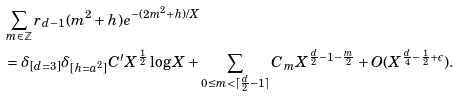Convert formula to latex. <formula><loc_0><loc_0><loc_500><loc_500>& \sum _ { m \in \mathbb { Z } } r _ { d - 1 } ( m ^ { 2 } + h ) e ^ { - ( 2 m ^ { 2 } + h ) / X } \\ & = \delta _ { [ d = 3 ] } \delta _ { [ h = a ^ { 2 } ] } C ^ { \prime } X ^ { \frac { 1 } { 2 } } \log X + \sum _ { 0 \leq m < \lceil \frac { d } { 2 } - 1 \rceil } C _ { m } X ^ { \frac { d } { 2 } - 1 - \frac { m } { 2 } } + O ( X ^ { \frac { d } { 4 } - \frac { 1 } { 2 } + \epsilon } ) .</formula> 